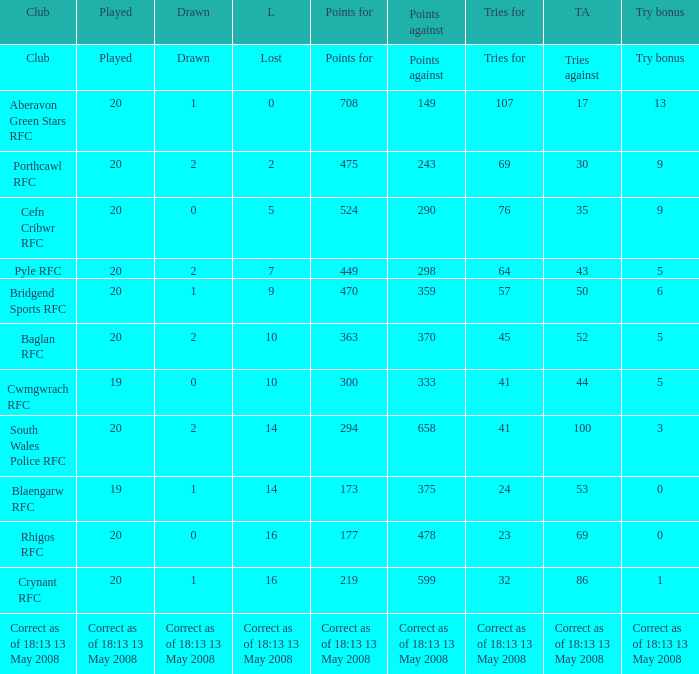What is the points number when 20 shows for played, and lost is 0? 708.0. 